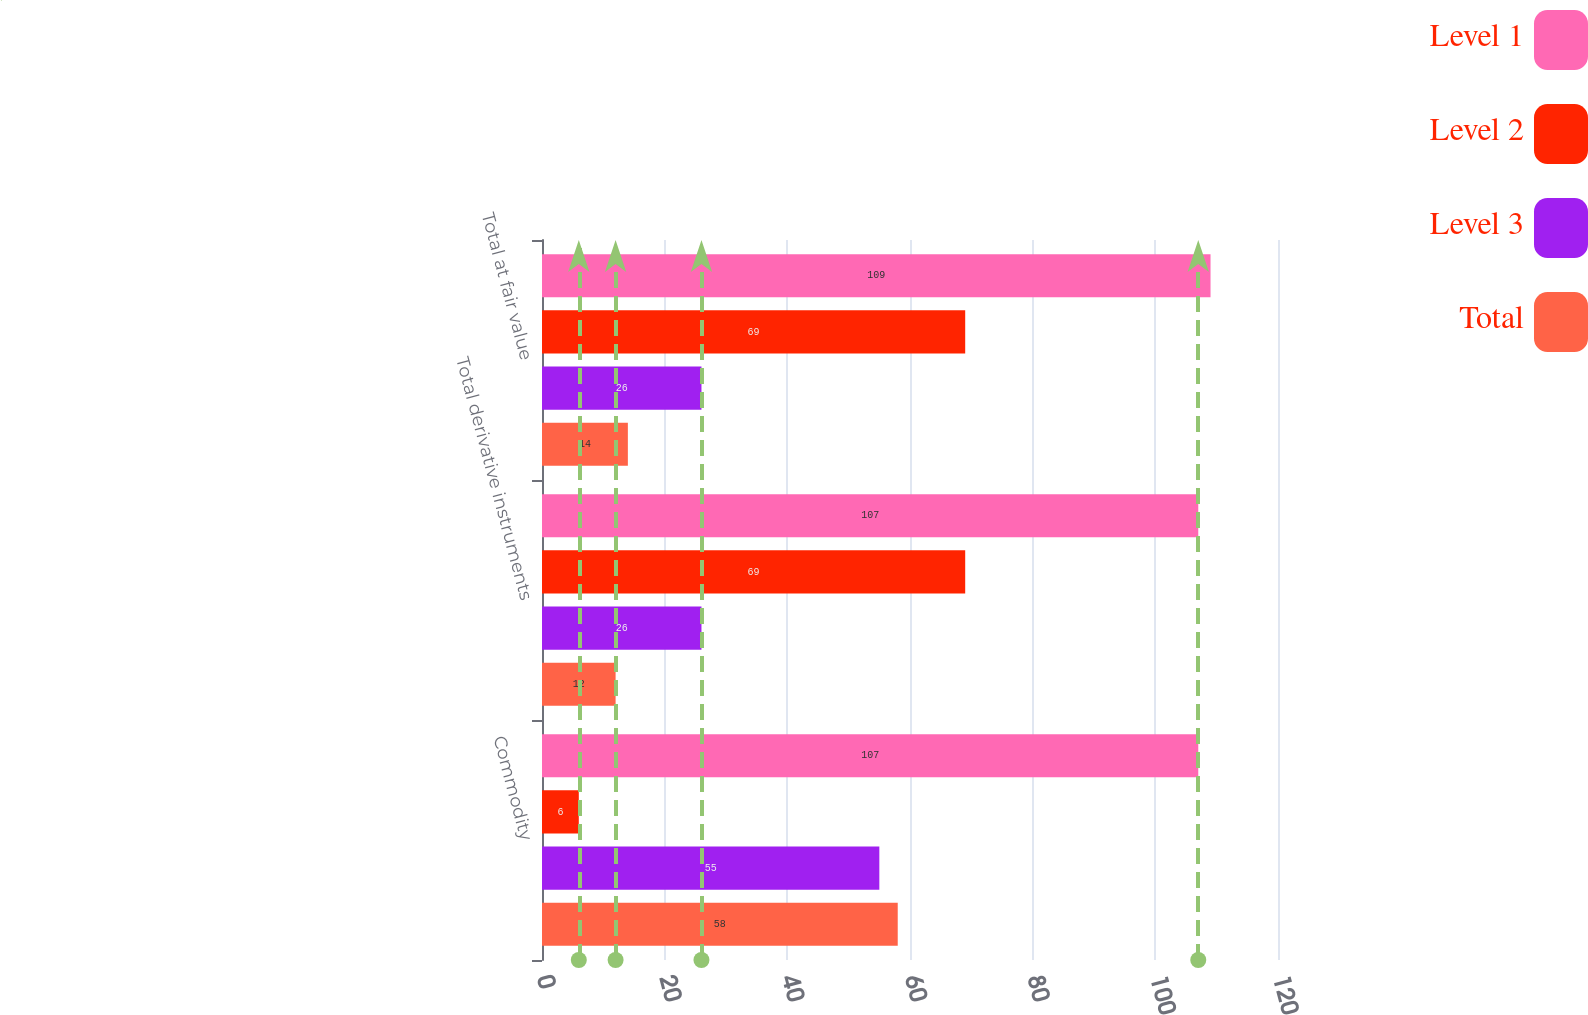Convert chart to OTSL. <chart><loc_0><loc_0><loc_500><loc_500><stacked_bar_chart><ecel><fcel>Commodity<fcel>Total derivative instruments<fcel>Total at fair value<nl><fcel>Level 1<fcel>107<fcel>107<fcel>109<nl><fcel>Level 2<fcel>6<fcel>69<fcel>69<nl><fcel>Level 3<fcel>55<fcel>26<fcel>26<nl><fcel>Total<fcel>58<fcel>12<fcel>14<nl></chart> 